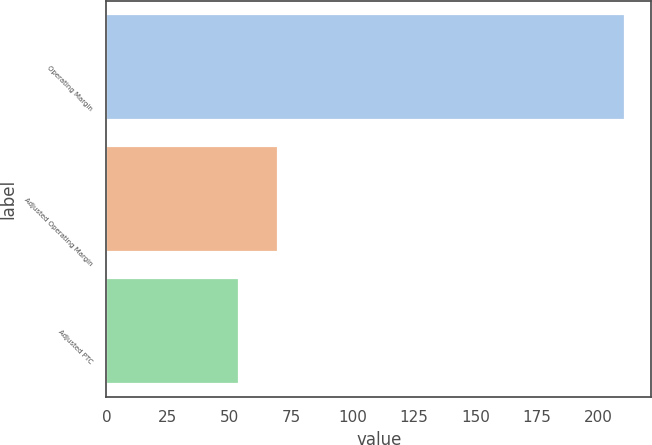Convert chart to OTSL. <chart><loc_0><loc_0><loc_500><loc_500><bar_chart><fcel>Operating Margin<fcel>Adjusted Operating Margin<fcel>Adjusted PTC<nl><fcel>211<fcel>69.7<fcel>54<nl></chart> 